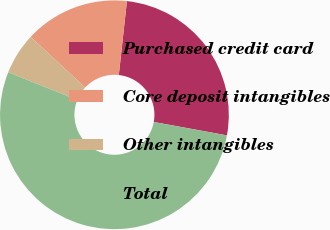Convert chart to OTSL. <chart><loc_0><loc_0><loc_500><loc_500><pie_chart><fcel>Purchased credit card<fcel>Core deposit intangibles<fcel>Other intangibles<fcel>Total<nl><fcel>26.14%<fcel>14.82%<fcel>5.87%<fcel>53.18%<nl></chart> 